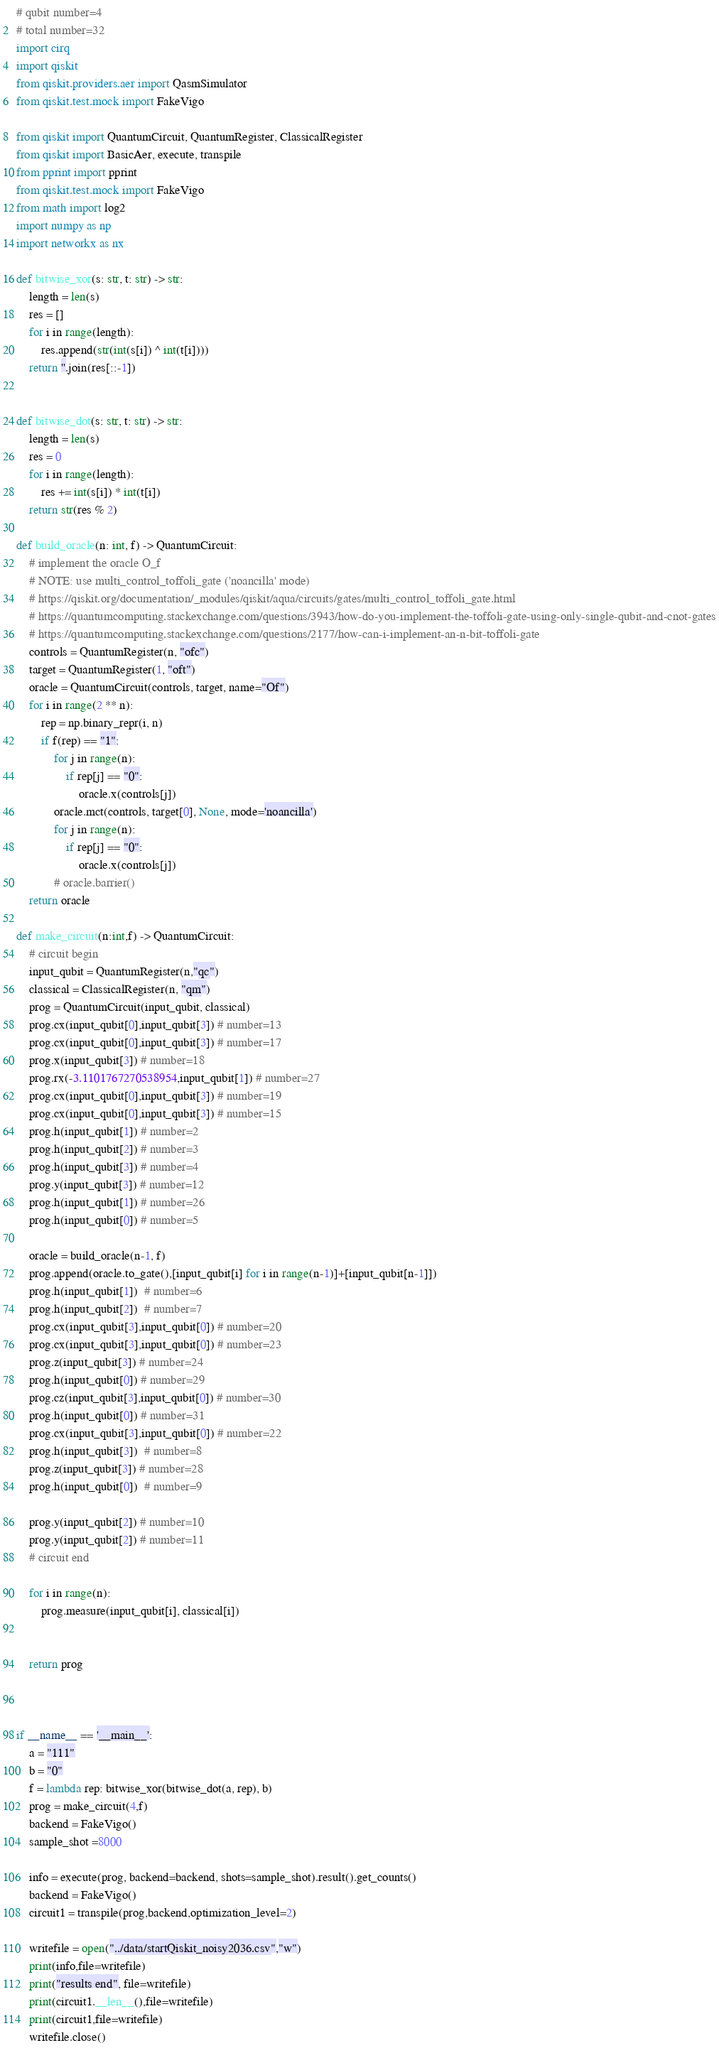Convert code to text. <code><loc_0><loc_0><loc_500><loc_500><_Python_># qubit number=4
# total number=32
import cirq
import qiskit
from qiskit.providers.aer import QasmSimulator
from qiskit.test.mock import FakeVigo

from qiskit import QuantumCircuit, QuantumRegister, ClassicalRegister
from qiskit import BasicAer, execute, transpile
from pprint import pprint
from qiskit.test.mock import FakeVigo
from math import log2
import numpy as np
import networkx as nx

def bitwise_xor(s: str, t: str) -> str:
    length = len(s)
    res = []
    for i in range(length):
        res.append(str(int(s[i]) ^ int(t[i])))
    return ''.join(res[::-1])


def bitwise_dot(s: str, t: str) -> str:
    length = len(s)
    res = 0
    for i in range(length):
        res += int(s[i]) * int(t[i])
    return str(res % 2)

def build_oracle(n: int, f) -> QuantumCircuit:
    # implement the oracle O_f
    # NOTE: use multi_control_toffoli_gate ('noancilla' mode)
    # https://qiskit.org/documentation/_modules/qiskit/aqua/circuits/gates/multi_control_toffoli_gate.html
    # https://quantumcomputing.stackexchange.com/questions/3943/how-do-you-implement-the-toffoli-gate-using-only-single-qubit-and-cnot-gates
    # https://quantumcomputing.stackexchange.com/questions/2177/how-can-i-implement-an-n-bit-toffoli-gate
    controls = QuantumRegister(n, "ofc")
    target = QuantumRegister(1, "oft")
    oracle = QuantumCircuit(controls, target, name="Of")
    for i in range(2 ** n):
        rep = np.binary_repr(i, n)
        if f(rep) == "1":
            for j in range(n):
                if rep[j] == "0":
                    oracle.x(controls[j])
            oracle.mct(controls, target[0], None, mode='noancilla')
            for j in range(n):
                if rep[j] == "0":
                    oracle.x(controls[j])
            # oracle.barrier()
    return oracle

def make_circuit(n:int,f) -> QuantumCircuit:
    # circuit begin
    input_qubit = QuantumRegister(n,"qc")
    classical = ClassicalRegister(n, "qm")
    prog = QuantumCircuit(input_qubit, classical)
    prog.cx(input_qubit[0],input_qubit[3]) # number=13
    prog.cx(input_qubit[0],input_qubit[3]) # number=17
    prog.x(input_qubit[3]) # number=18
    prog.rx(-3.1101767270538954,input_qubit[1]) # number=27
    prog.cx(input_qubit[0],input_qubit[3]) # number=19
    prog.cx(input_qubit[0],input_qubit[3]) # number=15
    prog.h(input_qubit[1]) # number=2
    prog.h(input_qubit[2]) # number=3
    prog.h(input_qubit[3]) # number=4
    prog.y(input_qubit[3]) # number=12
    prog.h(input_qubit[1]) # number=26
    prog.h(input_qubit[0]) # number=5

    oracle = build_oracle(n-1, f)
    prog.append(oracle.to_gate(),[input_qubit[i] for i in range(n-1)]+[input_qubit[n-1]])
    prog.h(input_qubit[1])  # number=6
    prog.h(input_qubit[2])  # number=7
    prog.cx(input_qubit[3],input_qubit[0]) # number=20
    prog.cx(input_qubit[3],input_qubit[0]) # number=23
    prog.z(input_qubit[3]) # number=24
    prog.h(input_qubit[0]) # number=29
    prog.cz(input_qubit[3],input_qubit[0]) # number=30
    prog.h(input_qubit[0]) # number=31
    prog.cx(input_qubit[3],input_qubit[0]) # number=22
    prog.h(input_qubit[3])  # number=8
    prog.z(input_qubit[3]) # number=28
    prog.h(input_qubit[0])  # number=9

    prog.y(input_qubit[2]) # number=10
    prog.y(input_qubit[2]) # number=11
    # circuit end

    for i in range(n):
        prog.measure(input_qubit[i], classical[i])


    return prog



if __name__ == '__main__':
    a = "111"
    b = "0"
    f = lambda rep: bitwise_xor(bitwise_dot(a, rep), b)
    prog = make_circuit(4,f)
    backend = FakeVigo()
    sample_shot =8000

    info = execute(prog, backend=backend, shots=sample_shot).result().get_counts()
    backend = FakeVigo()
    circuit1 = transpile(prog,backend,optimization_level=2)

    writefile = open("../data/startQiskit_noisy2036.csv","w")
    print(info,file=writefile)
    print("results end", file=writefile)
    print(circuit1.__len__(),file=writefile)
    print(circuit1,file=writefile)
    writefile.close()
</code> 